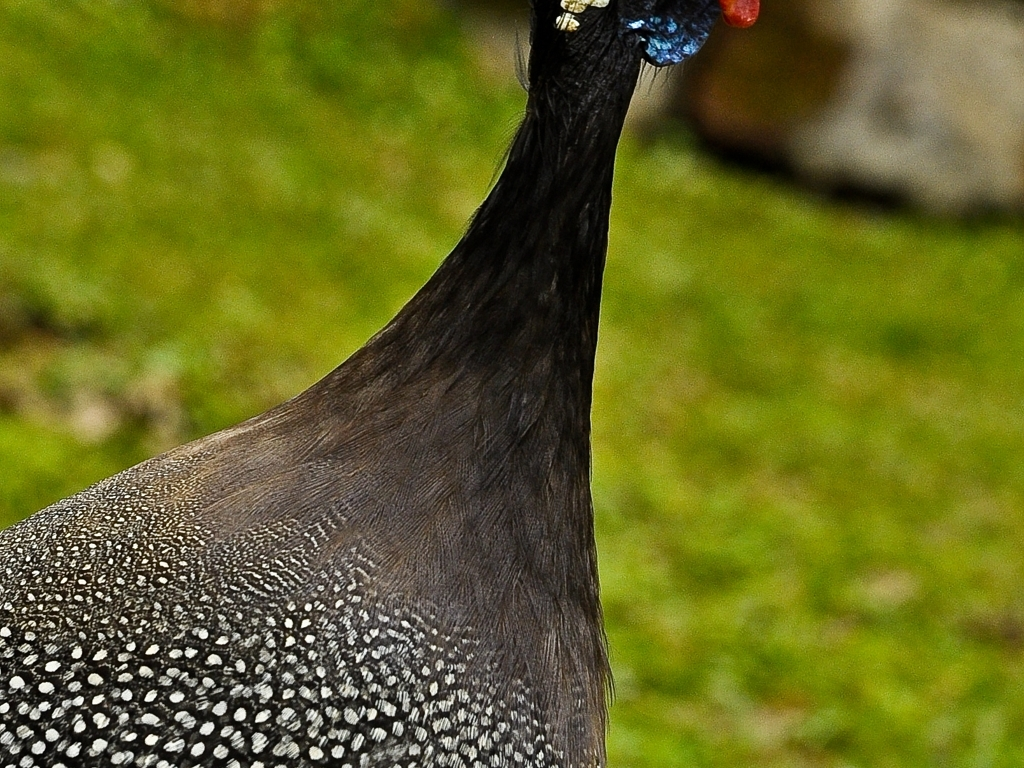What might the peacock's pose in this image suggest about its behavior or environment? The peacock's erect and alert posture, with its head held high and facing slightly towards the camera, may indicate a state of vigilance. This could suggest that it is aware of the photographer's presence or that it is simply scanning its environment, a behavior common when peacocks are on the lookout for predators or other peacocks. The background appears calm and green, likely signifying a peaceful natural habitat where the peacock can freely roam. 